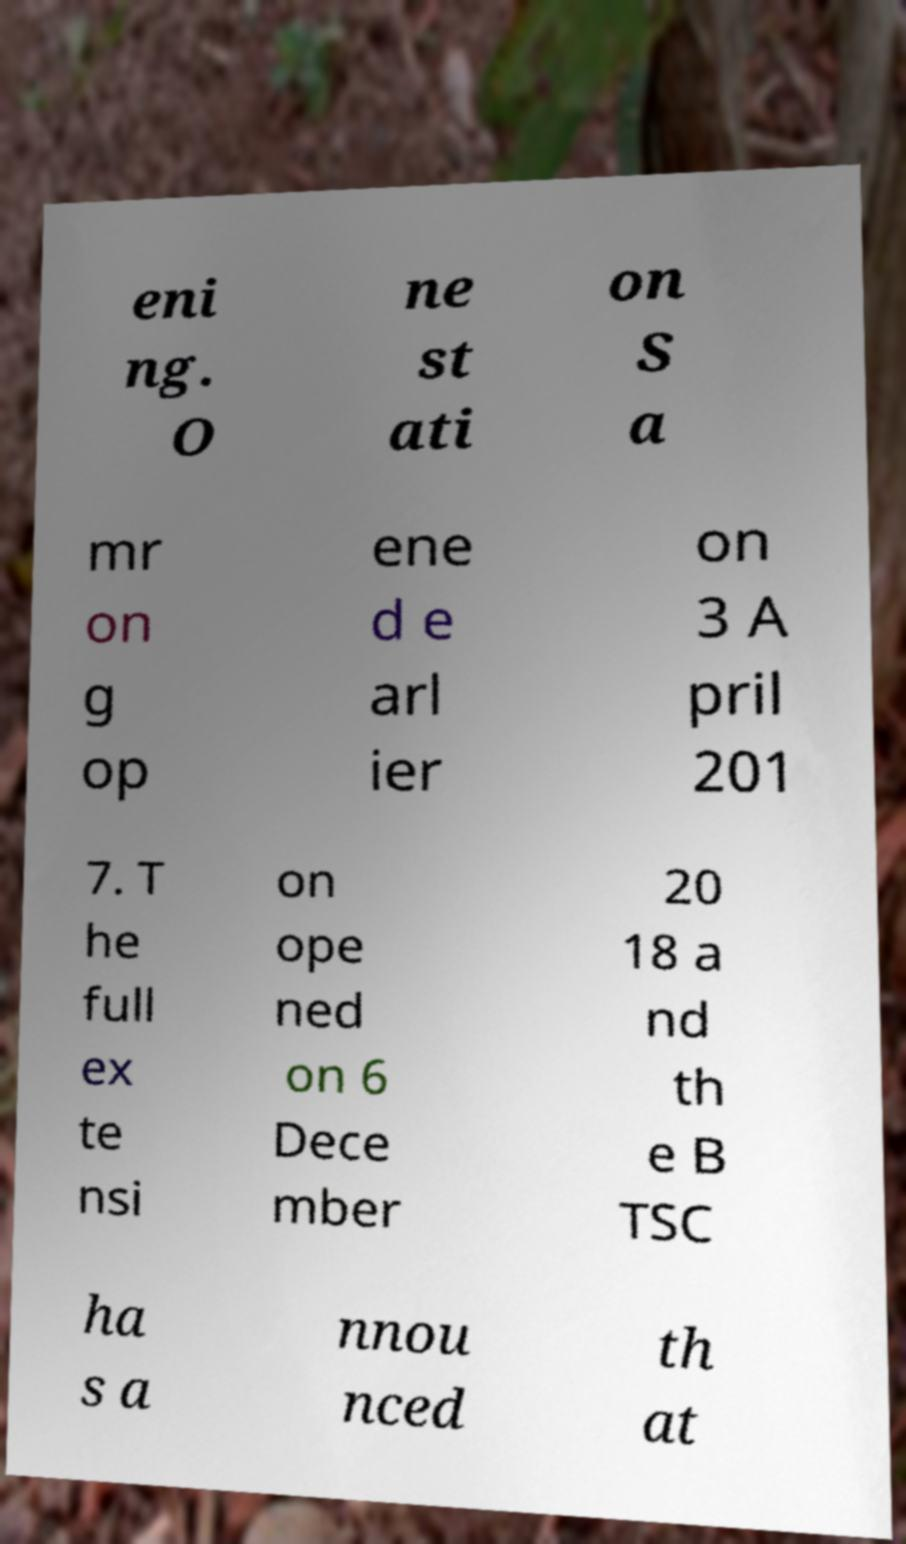There's text embedded in this image that I need extracted. Can you transcribe it verbatim? eni ng. O ne st ati on S a mr on g op ene d e arl ier on 3 A pril 201 7. T he full ex te nsi on ope ned on 6 Dece mber 20 18 a nd th e B TSC ha s a nnou nced th at 